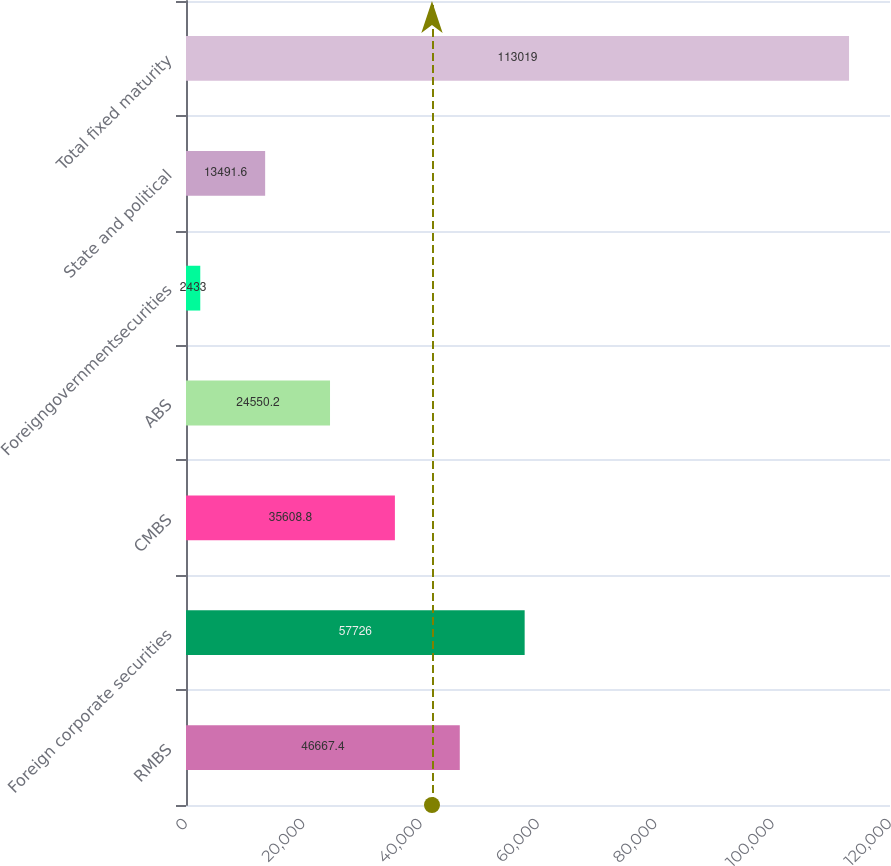Convert chart to OTSL. <chart><loc_0><loc_0><loc_500><loc_500><bar_chart><fcel>RMBS<fcel>Foreign corporate securities<fcel>CMBS<fcel>ABS<fcel>Foreigngovernmentsecurities<fcel>State and political<fcel>Total fixed maturity<nl><fcel>46667.4<fcel>57726<fcel>35608.8<fcel>24550.2<fcel>2433<fcel>13491.6<fcel>113019<nl></chart> 